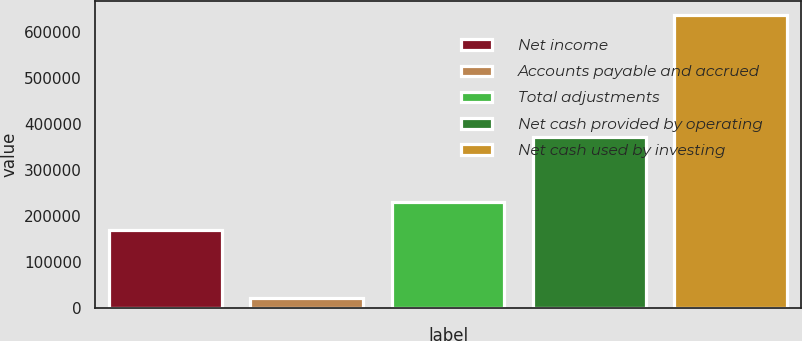Convert chart to OTSL. <chart><loc_0><loc_0><loc_500><loc_500><bar_chart><fcel>Net income<fcel>Accounts payable and accrued<fcel>Total adjustments<fcel>Net cash provided by operating<fcel>Net cash used by investing<nl><fcel>169081<fcel>21629<fcel>230427<fcel>371477<fcel>635089<nl></chart> 